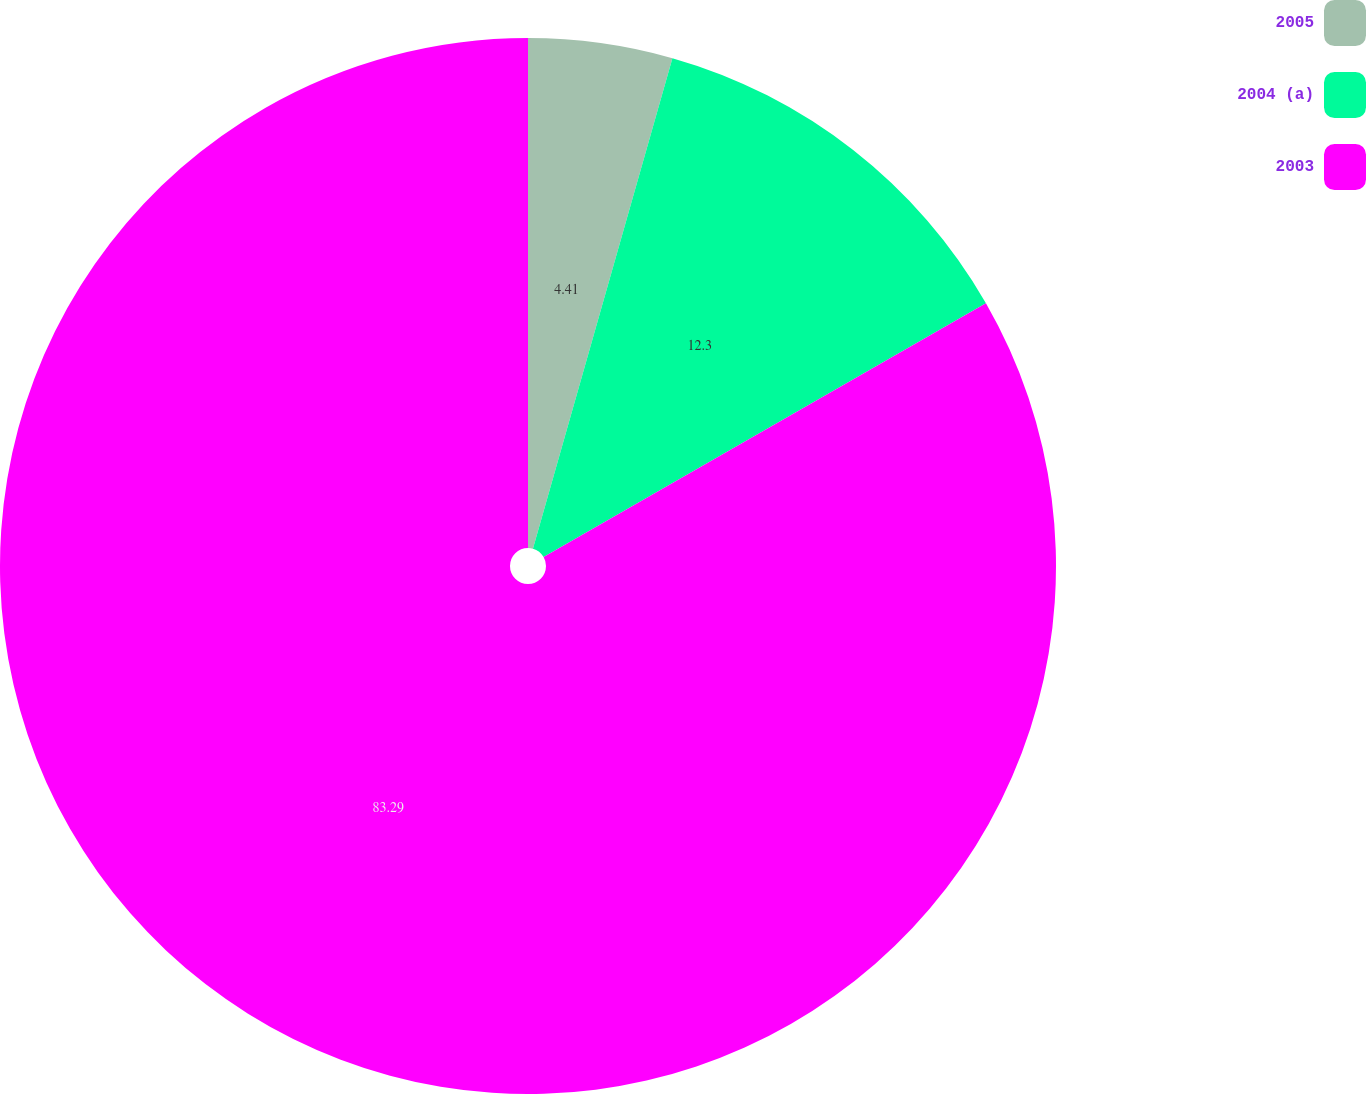<chart> <loc_0><loc_0><loc_500><loc_500><pie_chart><fcel>2005<fcel>2004 (a)<fcel>2003<nl><fcel>4.41%<fcel>12.3%<fcel>83.3%<nl></chart> 